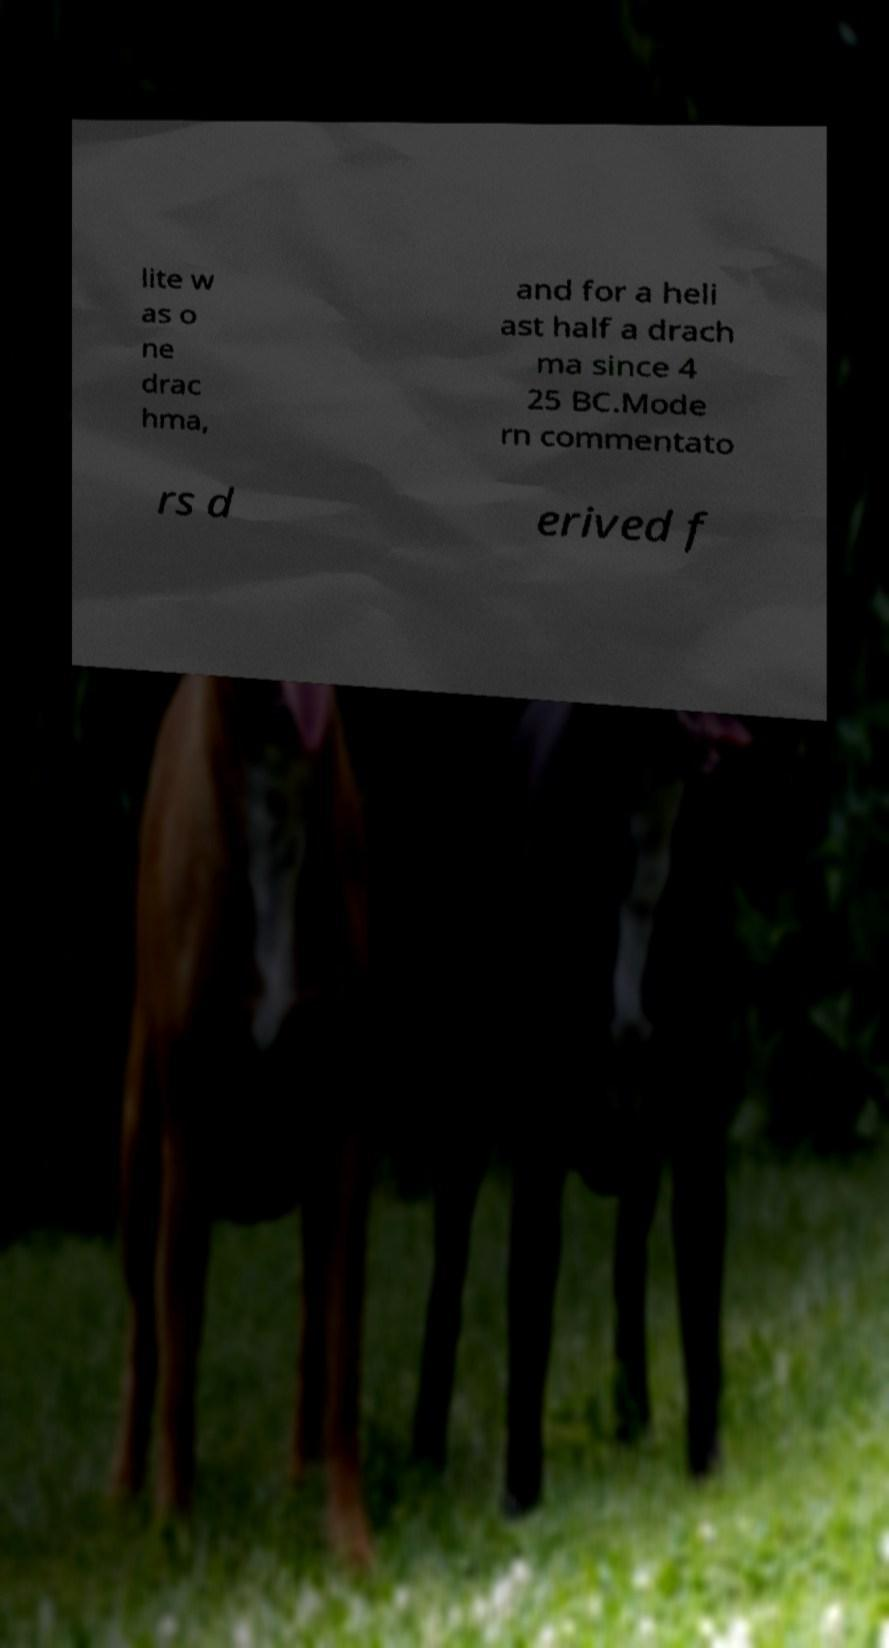What messages or text are displayed in this image? I need them in a readable, typed format. lite w as o ne drac hma, and for a heli ast half a drach ma since 4 25 BC.Mode rn commentato rs d erived f 